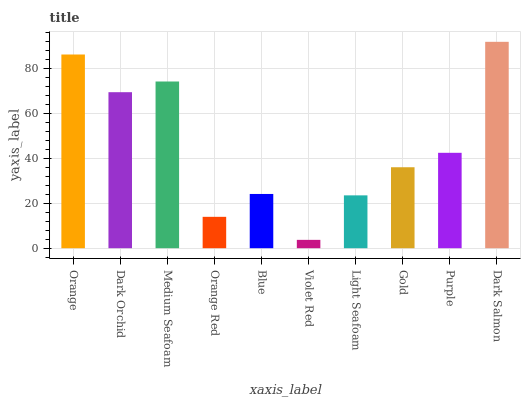Is Violet Red the minimum?
Answer yes or no. Yes. Is Dark Salmon the maximum?
Answer yes or no. Yes. Is Dark Orchid the minimum?
Answer yes or no. No. Is Dark Orchid the maximum?
Answer yes or no. No. Is Orange greater than Dark Orchid?
Answer yes or no. Yes. Is Dark Orchid less than Orange?
Answer yes or no. Yes. Is Dark Orchid greater than Orange?
Answer yes or no. No. Is Orange less than Dark Orchid?
Answer yes or no. No. Is Purple the high median?
Answer yes or no. Yes. Is Gold the low median?
Answer yes or no. Yes. Is Orange the high median?
Answer yes or no. No. Is Dark Orchid the low median?
Answer yes or no. No. 